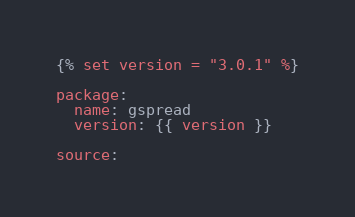Convert code to text. <code><loc_0><loc_0><loc_500><loc_500><_YAML_>{% set version = "3.0.1" %}

package:
  name: gspread
  version: {{ version }}

source:</code> 